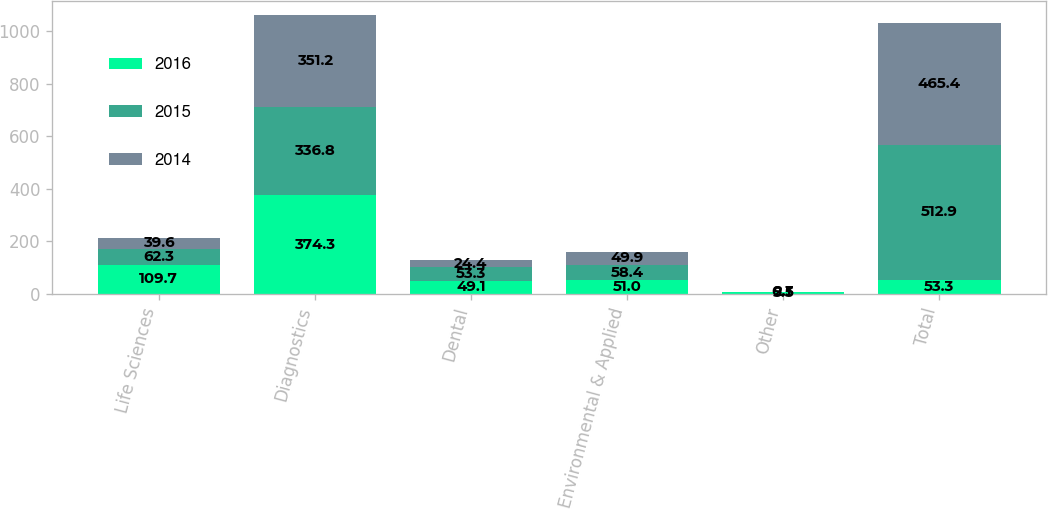Convert chart to OTSL. <chart><loc_0><loc_0><loc_500><loc_500><stacked_bar_chart><ecel><fcel>Life Sciences<fcel>Diagnostics<fcel>Dental<fcel>Environmental & Applied<fcel>Other<fcel>Total<nl><fcel>2016<fcel>109.7<fcel>374.3<fcel>49.1<fcel>51<fcel>5.5<fcel>53.3<nl><fcel>2015<fcel>62.3<fcel>336.8<fcel>53.3<fcel>58.4<fcel>2.1<fcel>512.9<nl><fcel>2014<fcel>39.6<fcel>351.2<fcel>24.4<fcel>49.9<fcel>0.3<fcel>465.4<nl></chart> 